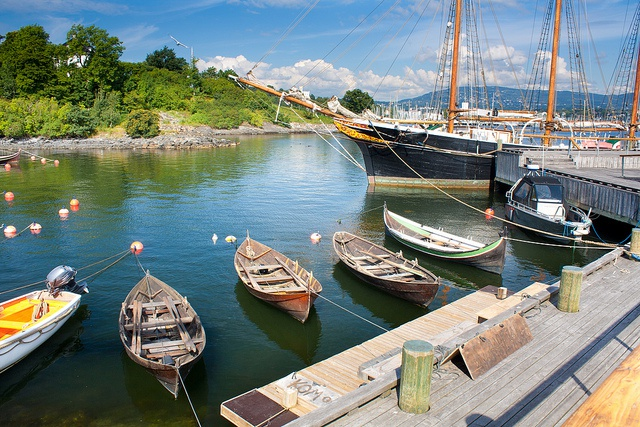Describe the objects in this image and their specific colors. I can see boat in gray, black, lightgray, and darkgray tones, boat in gray, black, darkgray, and tan tones, boat in gray, lightgray, tan, and darkgray tones, boat in gray, white, yellow, and darkgray tones, and boat in gray, black, white, and darkblue tones in this image. 